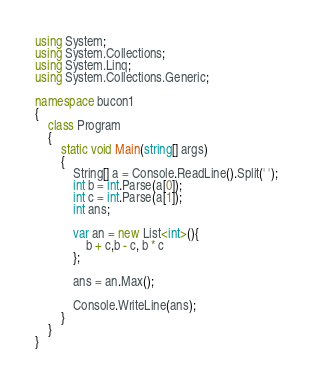<code> <loc_0><loc_0><loc_500><loc_500><_C#_>using System;
using System.Collections;
using System.Linq;
using System.Collections.Generic;

namespace bucon1
{
    class Program
    {
        static void Main(string[] args)
        {
            String[] a = Console.ReadLine().Split(' ');
            int b = int.Parse(a[0]);
            int c = int.Parse(a[1]);
            int ans;

            var an = new List<int>(){
                b + c,b - c, b * c
            };

            ans = an.Max();
            
            Console.WriteLine(ans);
        }
    }
}
</code> 